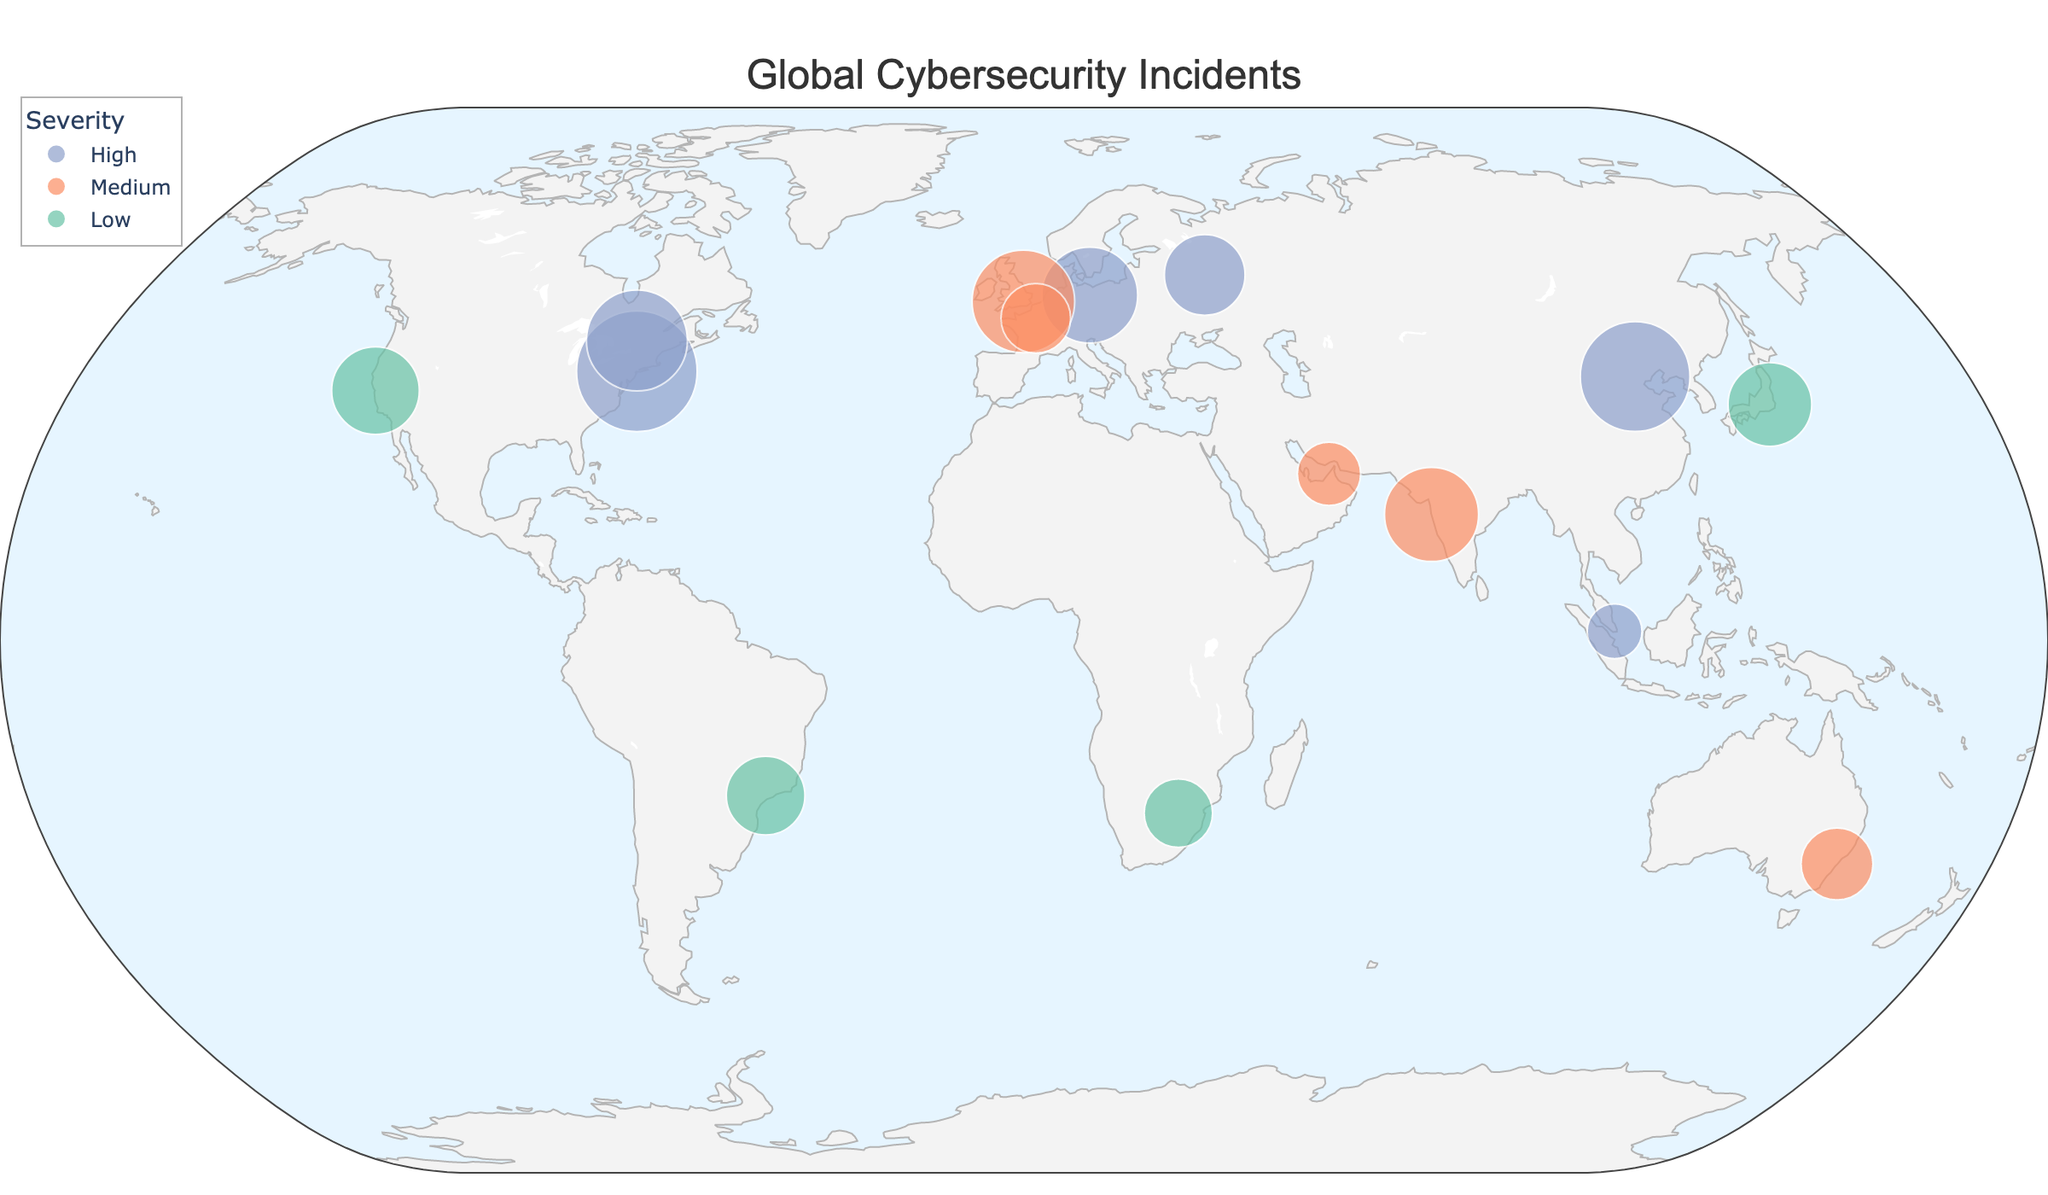What is the title of the plot? The title is displayed prominently at the top center of the figure. It reads "Global Cybersecurity Incidents".
Answer: Global Cybersecurity Incidents Which city has the highest number of cybersecurity incidents? By looking at the size of the circles on the plot, New York City has the largest circle, indicating it has the highest number of incidents, which is confirmed by the hover data showing 87 incidents.
Answer: New York Which country has incidents classified as man-in-the-middle attacks? Hover over the circles to find the one with "Man-in-the-Middle" in the hover data. Paris in France displays this type of attack.
Answer: France What is the severity level and number of incidents for the attack in Beijing? Hover over the circle representing Beijing to see the details. The hover data shows an 'Advanced Persistent Threat' attack with a 'High' severity level and 72 incidents.
Answer: High, 72 Compare the number of incidents between London and Tokyo. Which one has more? Hover over both London and Tokyo circles and compare the values. London has 63 incidents, while Tokyo has 42 incidents.
Answer: London What is the common feature color of attacks with high severity? High severity attacks are represented by color-coded circles. The color for high severity incidents appears as purple.
Answer: Purple How many incidents were reported in cities with a 'Medium' severity level? Three cities with medium severity are London (63), Sydney (31), Paris (29), Mumbai (53), and Dubai (24). Summing these gives 63 + 31 + 29 + 53 + 24 = 200.
Answer: 200 Which city has the lowest number of incidents, and what type of attack occurred there? Hover over each city's circle to find the smallest incident count. Singapore has the lowest number of incidents (18) with a 'Zero-day Exploit' attack.
Answer: Singapore, Zero-day Exploit Compare the number and severity of incidents in New York and Berlin. How do they differ? Hover over New York and Berlin for details. New York has 87 high severity incidents (Ransomware), Berlin has 55 high severity incidents (Malware). New York has more incidents but both are high severity.
Answer: New York has more incidents, both high severity In which continents are the high severity incidents concentrated? By hovering over the circles and observing their locations, high severity incidents are concentrated in North America (New York, Ottawa), Asia (Beijing, Singapore), and Europe (Berlin, Moscow).
Answer: North America, Asia, Europe 